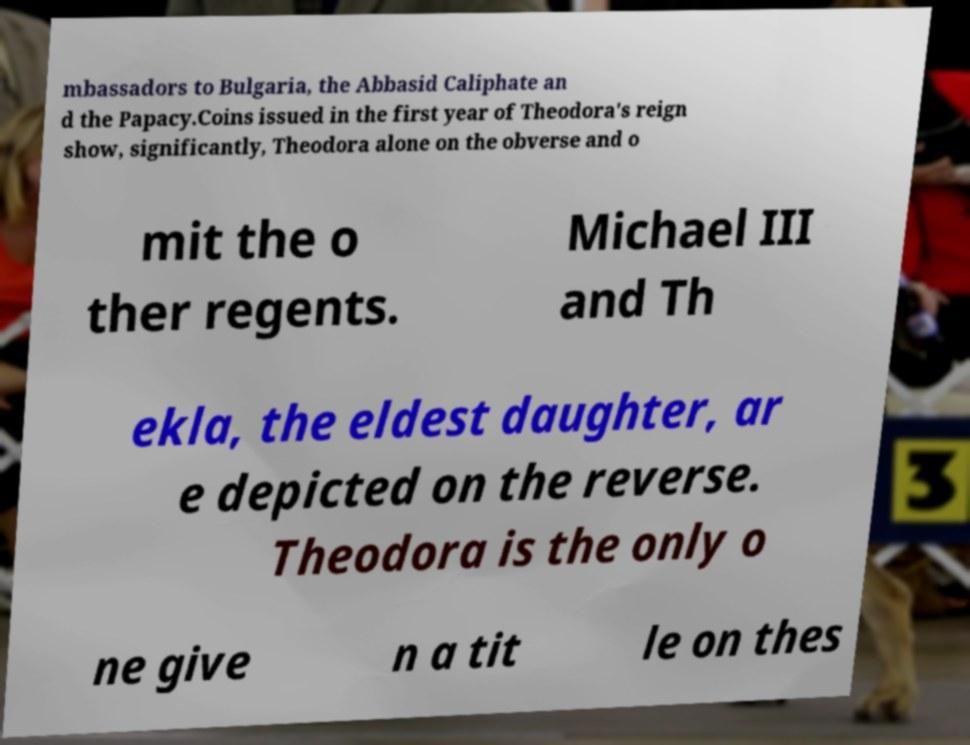I need the written content from this picture converted into text. Can you do that? mbassadors to Bulgaria, the Abbasid Caliphate an d the Papacy.Coins issued in the first year of Theodora's reign show, significantly, Theodora alone on the obverse and o mit the o ther regents. Michael III and Th ekla, the eldest daughter, ar e depicted on the reverse. Theodora is the only o ne give n a tit le on thes 